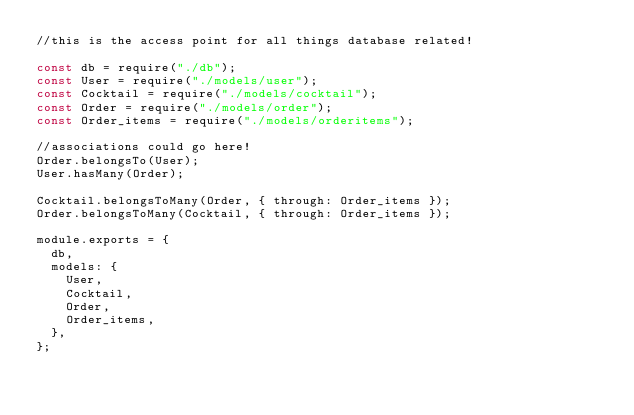Convert code to text. <code><loc_0><loc_0><loc_500><loc_500><_JavaScript_>//this is the access point for all things database related!

const db = require("./db");
const User = require("./models/user");
const Cocktail = require("./models/cocktail");
const Order = require("./models/order");
const Order_items = require("./models/orderitems");

//associations could go here!
Order.belongsTo(User);
User.hasMany(Order);

Cocktail.belongsToMany(Order, { through: Order_items });
Order.belongsToMany(Cocktail, { through: Order_items });

module.exports = {
  db,
  models: {
    User,
    Cocktail,
    Order,
    Order_items,
  },
};
</code> 